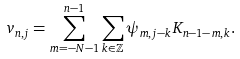Convert formula to latex. <formula><loc_0><loc_0><loc_500><loc_500>v _ { n , j } = \sum _ { m = - N - 1 } ^ { n - 1 } \sum _ { k \in \mathbb { Z } } \psi _ { m , j - k } K _ { n - 1 - m , k } .</formula> 